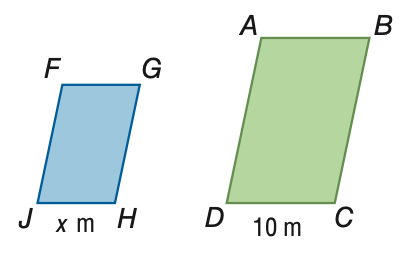Answer the mathemtical geometry problem and directly provide the correct option letter.
Question: The area of \parallelogram A B C D is 150 square meters. The area of \parallelogram F G H J is 54 square meters. If \parallelogram A B C D \sim \parallelogram F G H J, find the scale factor of \parallelogram F G H J to \parallelogram A B C D.
Choices: A: \frac { 9 } { 25 } B: \frac { 3 } { 5 } C: \frac { 5 } { 3 } D: \frac { 25 } { 9 } B 